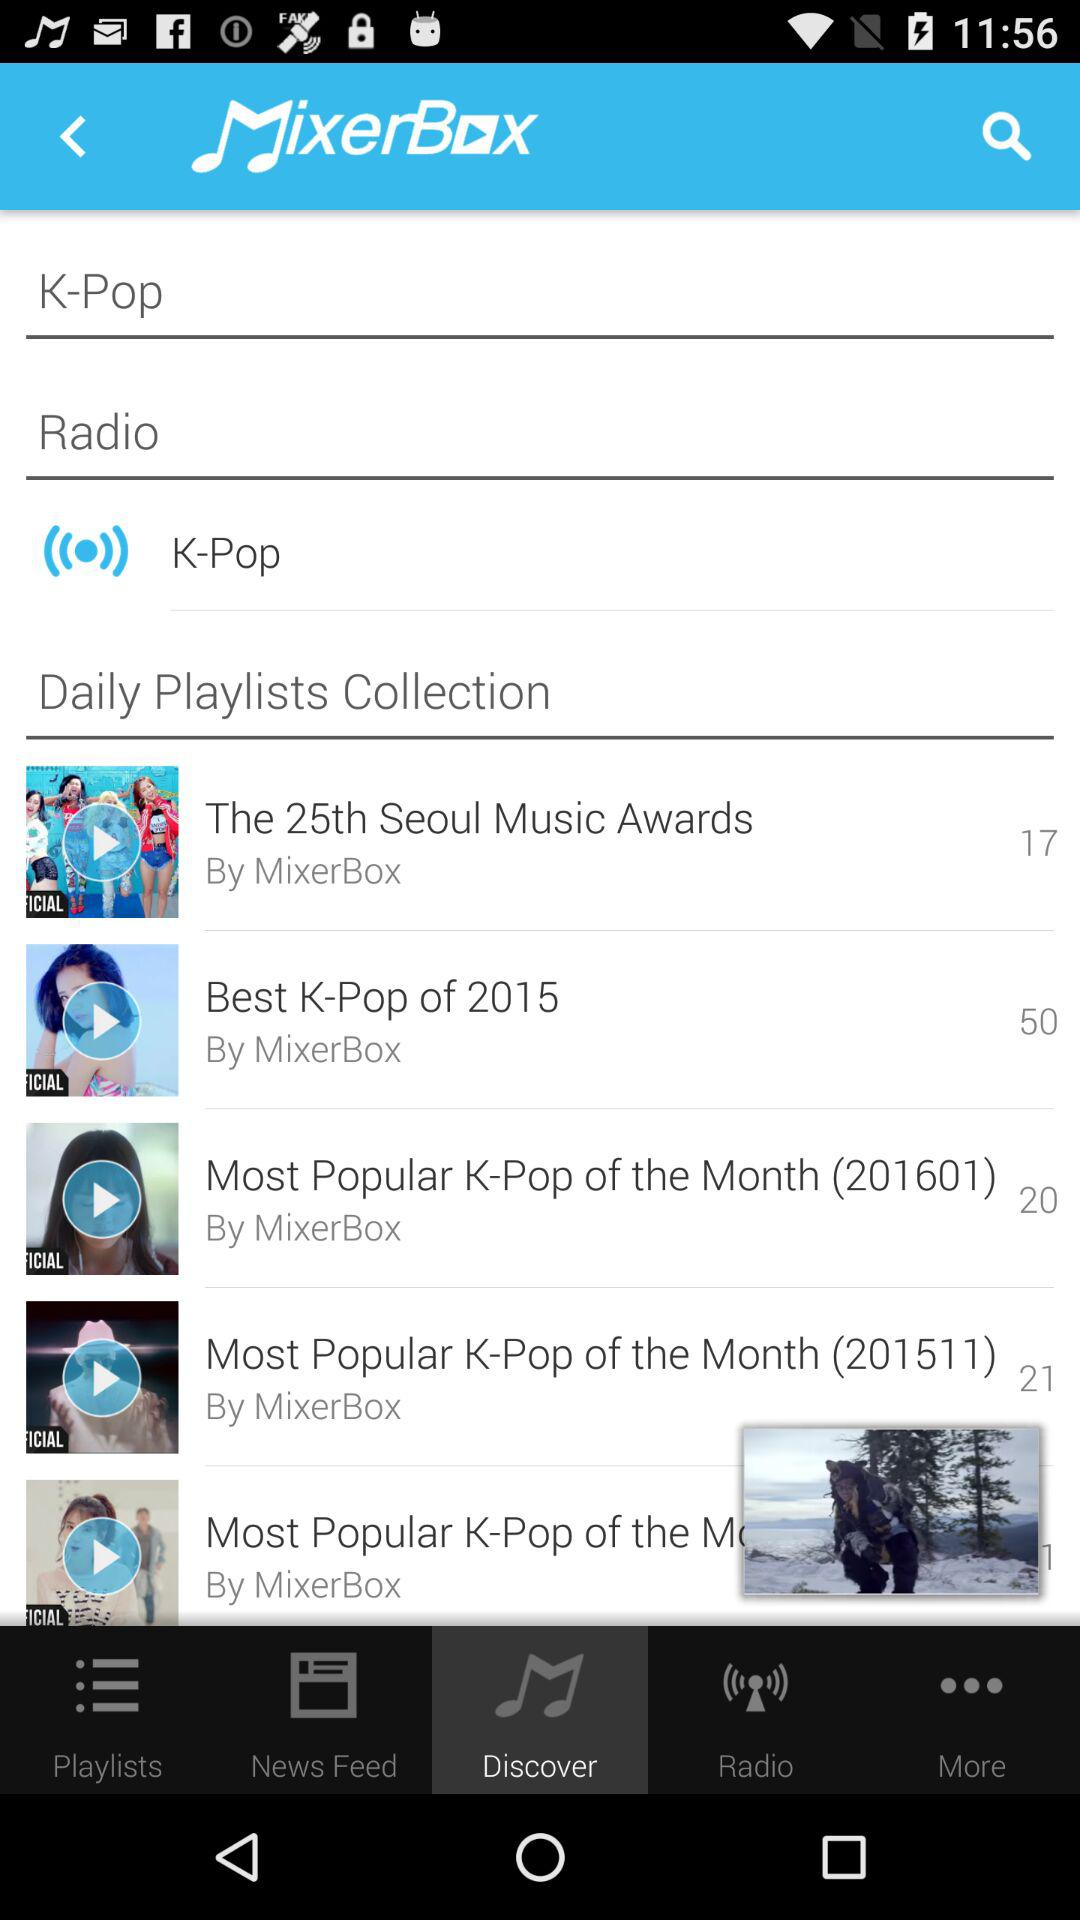Which tab is selected? The selected tab is "Discover". 